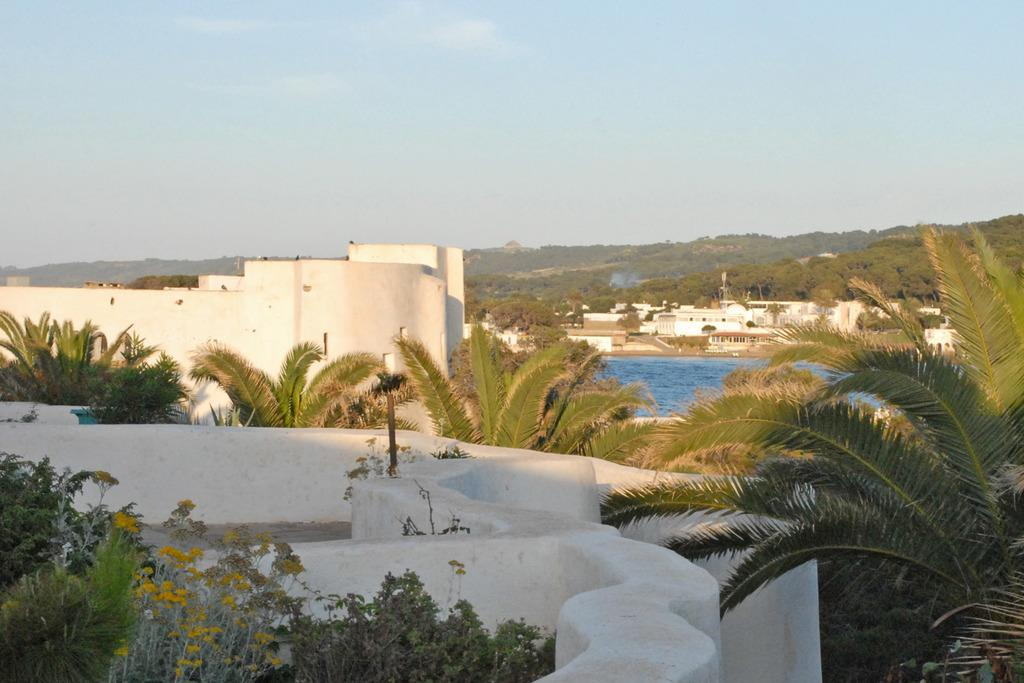What type of vegetation can be seen in the image? There are trees and plants with flowers in the image. Where was the image likely taken from? The image appears to be taken from a terrace. What structures can be seen in the image? There are buildings visible in the image. What natural feature is present in the image? There is a body of water in the image. What might be visible in the distance in the image? The image may depict hills in the background. Reasoning: Let'ing: Let's think step by step in order to produce the conversation. We start by identifying the main subjects in the image, which are the trees and plants with flowers. Then, we describe the location from which the image was likely taken, which is a terrace. Next, we mention the presence of buildings, which are man-made structures visible in the image. We then describe the natural feature present in the image, which is a body of water. Finally, we speculate about what might be visible in the distance, which is hills in the background. Absurd Question/Answer: What language is spoken by the suit in the image? There is no suit present in the image, and therefore no language can be attributed to it. 